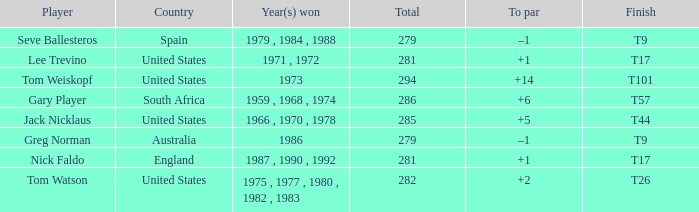Who has the highest total and a to par of +14? 294.0. 